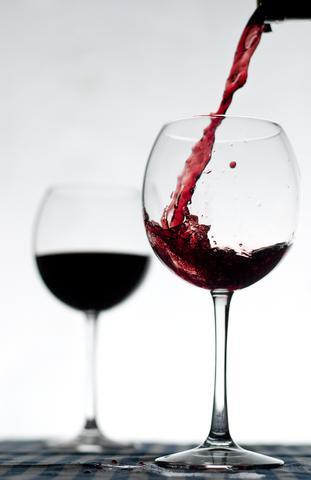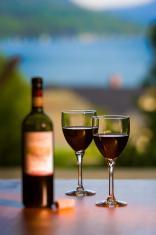The first image is the image on the left, the second image is the image on the right. Given the left and right images, does the statement "The right image has two wine glasses with a bottle of wine to the left of them." hold true? Answer yes or no. Yes. The first image is the image on the left, the second image is the image on the right. Evaluate the accuracy of this statement regarding the images: "There are two half filled wine glasses next to the bottle in the right image.". Is it true? Answer yes or no. Yes. 